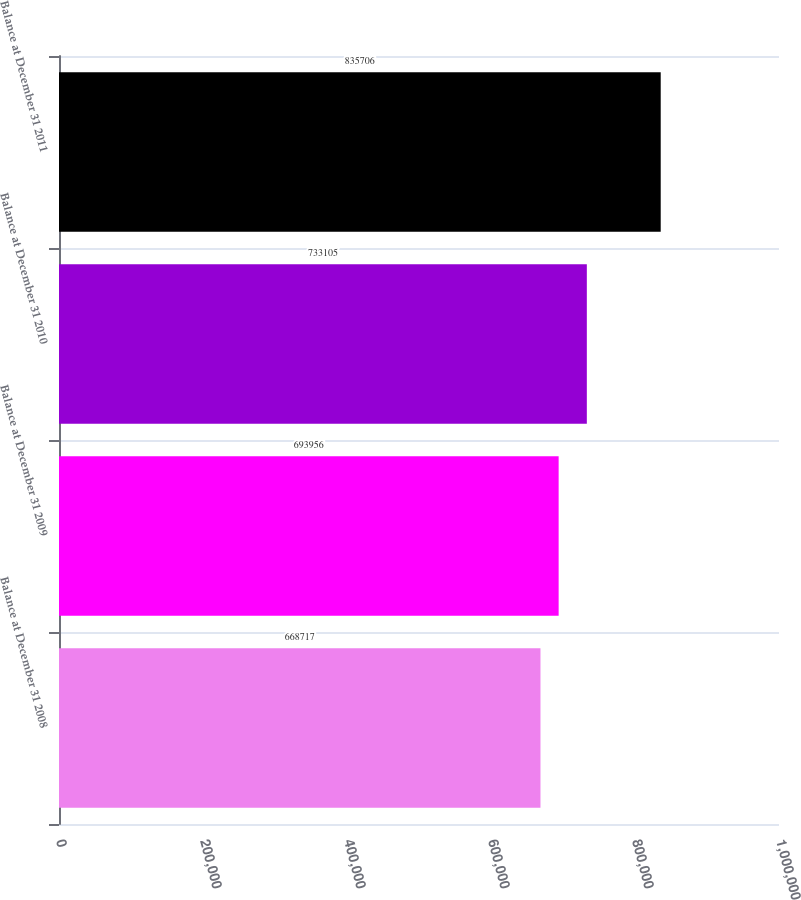<chart> <loc_0><loc_0><loc_500><loc_500><bar_chart><fcel>Balance at December 31 2008<fcel>Balance at December 31 2009<fcel>Balance at December 31 2010<fcel>Balance at December 31 2011<nl><fcel>668717<fcel>693956<fcel>733105<fcel>835706<nl></chart> 